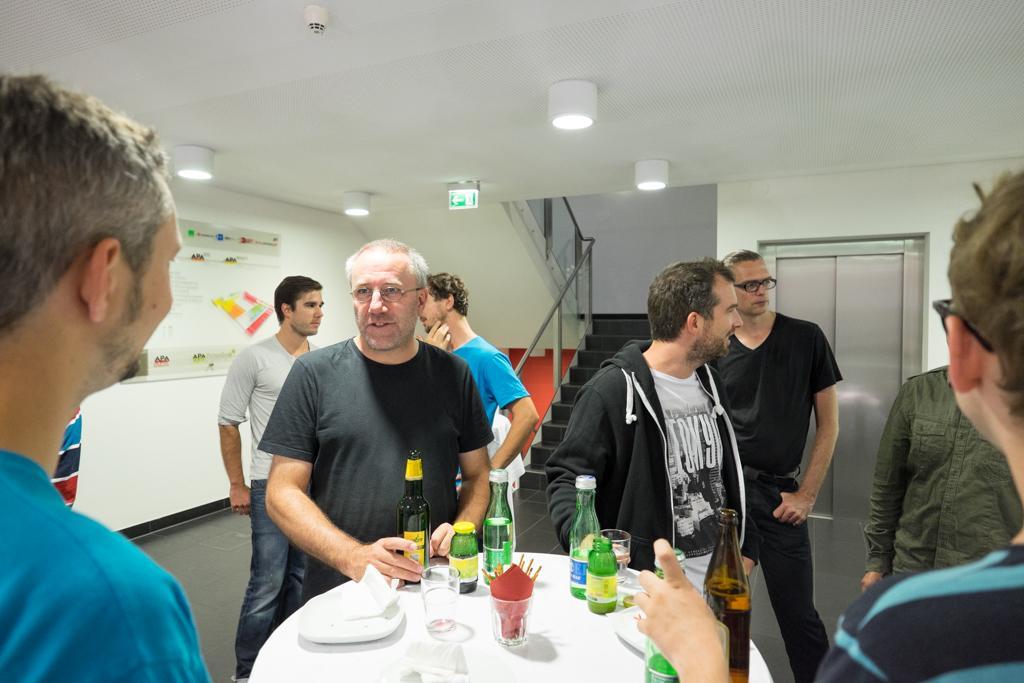Please provide a concise description of this image. In this picture we can see persons standing and talking in front of them there is table and on table we can see glass, bottle, tissue paper, plate, stand and in the background we can see wall, light, sign board, fence, lift door. 